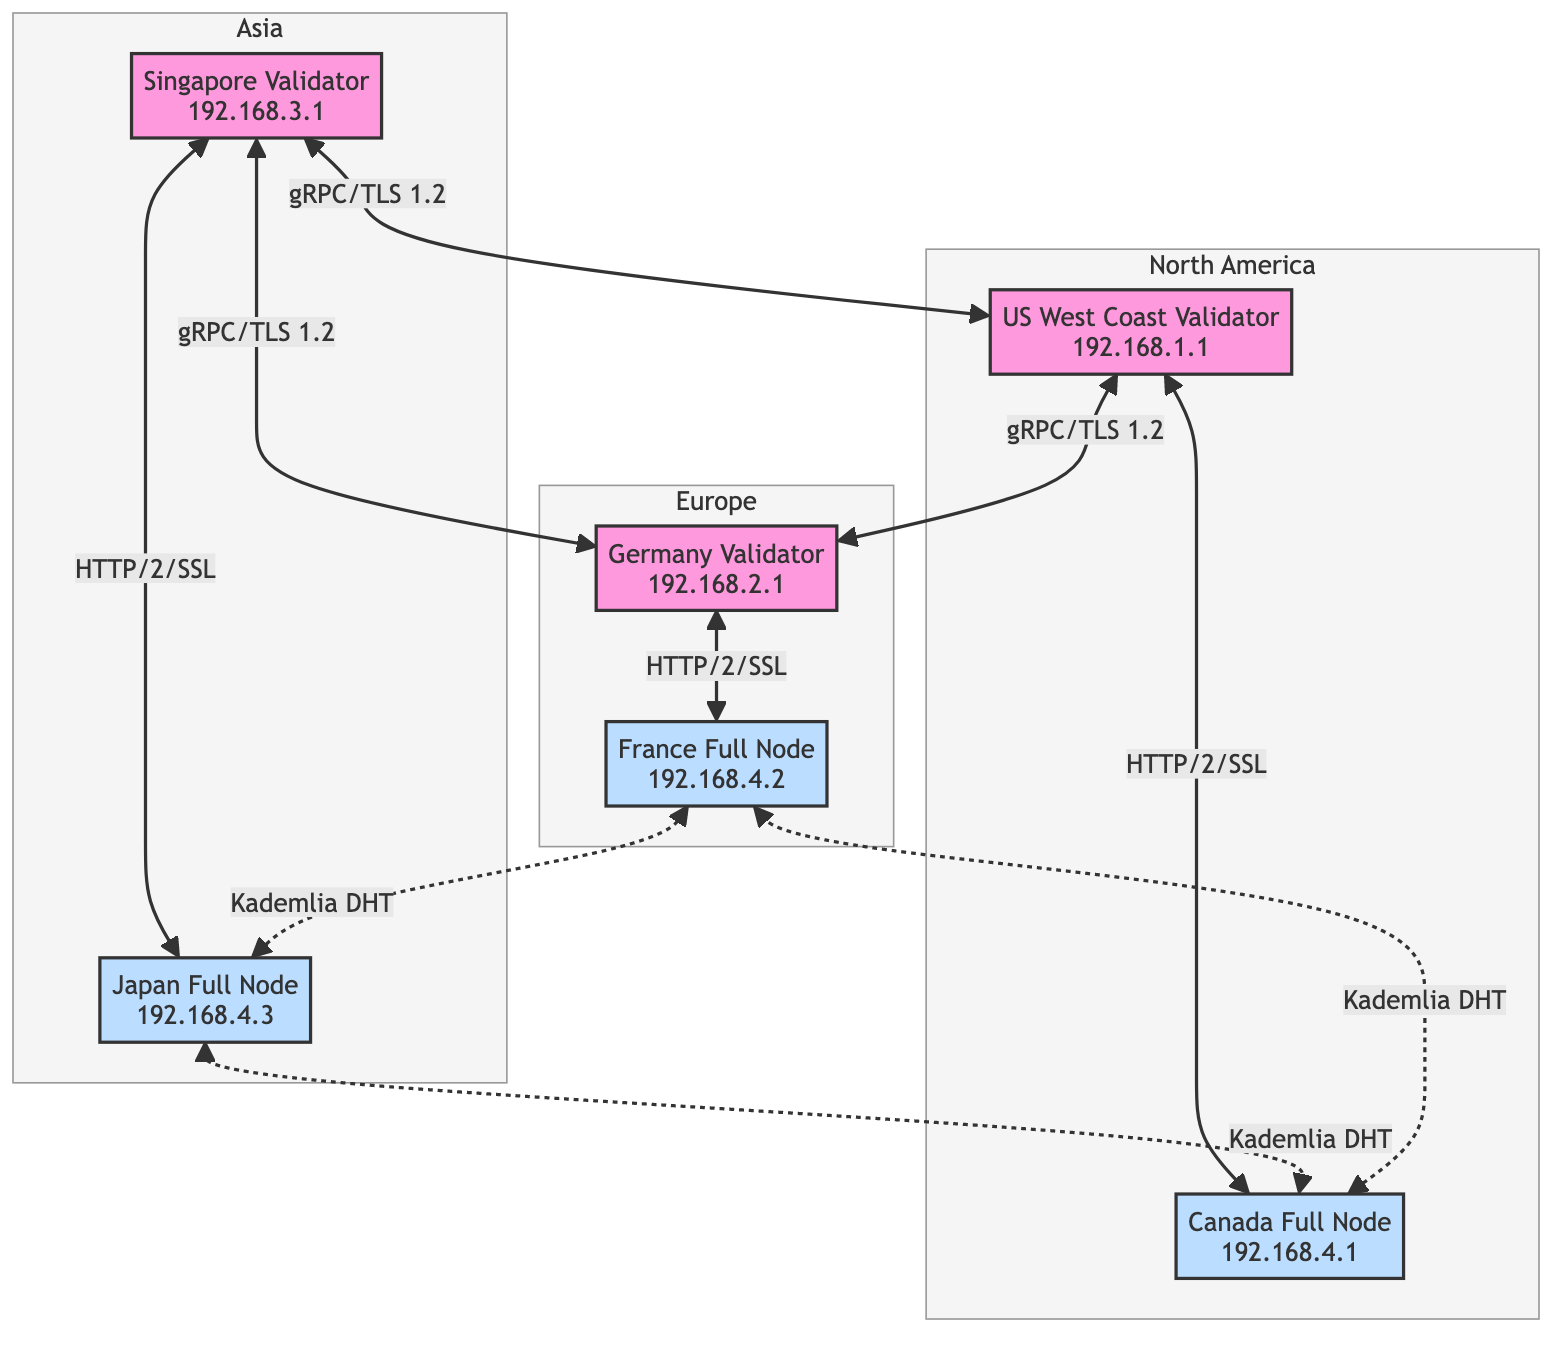What is the location of the US West Coast Validator? The diagram indicates that the US West Coast Validator is located in North America.
Answer: North America How many validator nodes are in the diagram? By examining the nodes represented in the diagram, there are a total of three validator nodes: US West Coast Validator, Germany Validator, and Singapore Validator.
Answer: 3 What communication protocol is used between the validator nodes? The diagram shows that the communication protocol used between the validator nodes is gRPC with TLS 1.2 encryption.
Answer: gRPC/TLS 1.2 Which full node is located in Japan? The diagram lists the full node located in Japan as Japan Full Node with the respective IP address.
Answer: Japan Full Node What protocol is used for syncing between full nodes? According to the diagram, full nodes sync data using the HTTP/2 protocol with SSL encryption.
Answer: HTTP/2/SSL Which nodes use Kademlia DHT for peer discovery? The diagram specifies that Kademlia DHT is used for peer discovery among all full nodes: Canada Full Node, France Full Node, and Japan Full Node.
Answer: Canada Full Node, France Full Node, Japan Full Node How many total nodes are represented in the diagram? By counting all nodes in the diagram, there are a total of six: three validator nodes and three full nodes.
Answer: 6 Which geographic region has the most nodes? Analyzing the distribution, Europe has more nodes, as it contains two nodes (Germany Validator and France Full Node), compared to the other regions, which each have two nodes.
Answer: Europe What type of node is associated with the IP address 192.168.4.1? The IP address 192.168.4.1 is associated with a full node according to the provided diagram.
Answer: Full Node 